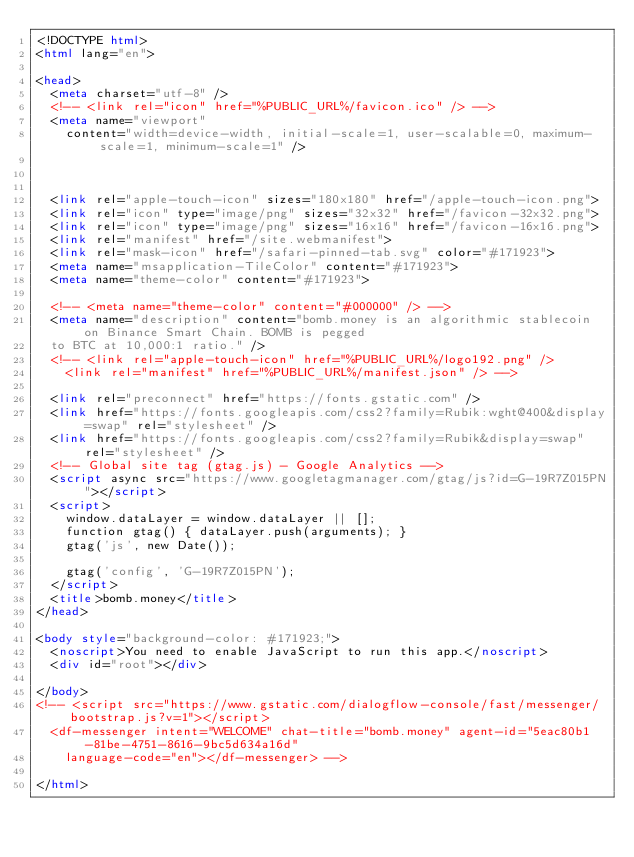Convert code to text. <code><loc_0><loc_0><loc_500><loc_500><_HTML_><!DOCTYPE html>
<html lang="en">

<head>
  <meta charset="utf-8" />
  <!-- <link rel="icon" href="%PUBLIC_URL%/favicon.ico" /> -->
  <meta name="viewport"
    content="width=device-width, initial-scale=1, user-scalable=0, maximum-scale=1, minimum-scale=1" />



  <link rel="apple-touch-icon" sizes="180x180" href="/apple-touch-icon.png">
  <link rel="icon" type="image/png" sizes="32x32" href="/favicon-32x32.png">
  <link rel="icon" type="image/png" sizes="16x16" href="/favicon-16x16.png">
  <link rel="manifest" href="/site.webmanifest">
  <link rel="mask-icon" href="/safari-pinned-tab.svg" color="#171923">
  <meta name="msapplication-TileColor" content="#171923">
  <meta name="theme-color" content="#171923">

  <!-- <meta name="theme-color" content="#000000" /> -->
  <meta name="description" content="bomb.money is an algorithmic stablecoin on Binance Smart Chain. BOMB is pegged
  to BTC at 10,000:1 ratio." />
  <!-- <link rel="apple-touch-icon" href="%PUBLIC_URL%/logo192.png" />
    <link rel="manifest" href="%PUBLIC_URL%/manifest.json" /> -->

  <link rel="preconnect" href="https://fonts.gstatic.com" />
  <link href="https://fonts.googleapis.com/css2?family=Rubik:wght@400&display=swap" rel="stylesheet" />
  <link href="https://fonts.googleapis.com/css2?family=Rubik&display=swap" rel="stylesheet" />
  <!-- Global site tag (gtag.js) - Google Analytics -->
  <script async src="https://www.googletagmanager.com/gtag/js?id=G-19R7Z015PN"></script>
  <script>
    window.dataLayer = window.dataLayer || [];
    function gtag() { dataLayer.push(arguments); }
    gtag('js', new Date());

    gtag('config', 'G-19R7Z015PN');
  </script>
  <title>bomb.money</title>
</head>

<body style="background-color: #171923;">
  <noscript>You need to enable JavaScript to run this app.</noscript>
  <div id="root"></div>

</body>
<!-- <script src="https://www.gstatic.com/dialogflow-console/fast/messenger/bootstrap.js?v=1"></script>
  <df-messenger intent="WELCOME" chat-title="bomb.money" agent-id="5eac80b1-81be-4751-8616-9bc5d634a16d"
    language-code="en"></df-messenger> -->

</html></code> 